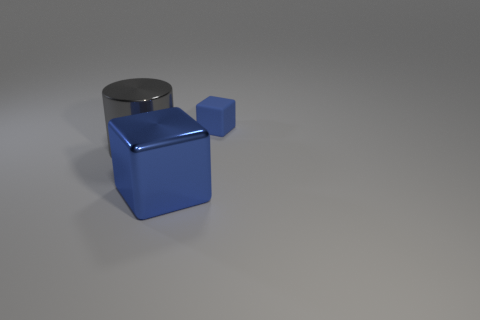Add 2 shiny cylinders. How many objects exist? 5 Subtract all small yellow cylinders. Subtract all tiny objects. How many objects are left? 2 Add 1 small cubes. How many small cubes are left? 2 Add 2 large gray metal cylinders. How many large gray metal cylinders exist? 3 Subtract 0 brown spheres. How many objects are left? 3 Subtract all cubes. How many objects are left? 1 Subtract all green cubes. Subtract all cyan balls. How many cubes are left? 2 